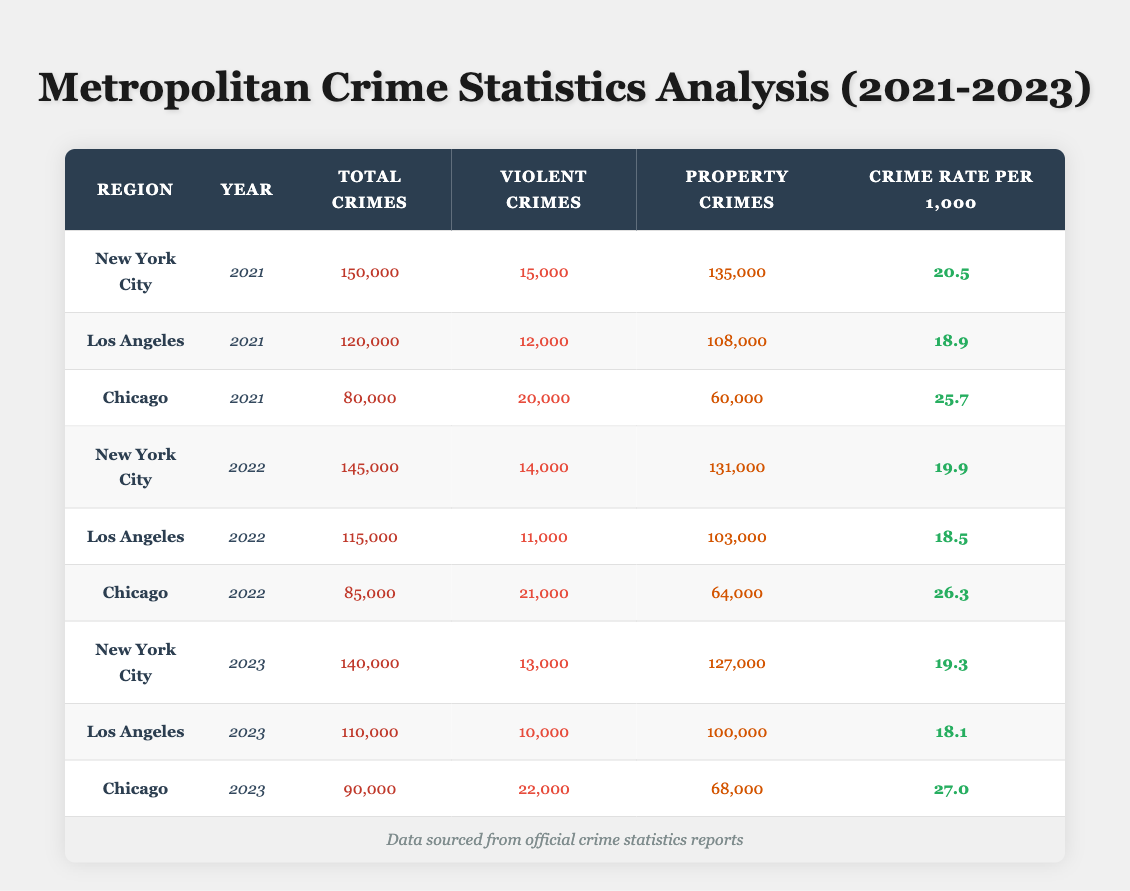What is the total number of violent crimes reported in Chicago in 2022? In the 2022 row for Chicago, the table shows that the number of violent crimes is listed as 21,000.
Answer: 21,000 How many total crimes were reported in Los Angeles in 2021? Referring to the 2021 row for Los Angeles in the table, the total crimes are stated as 120,000.
Answer: 120,000 What was the crime rate per 1,000 people in New York City in 2023? Looking at the 2023 row for New York City, the crime rate per 1,000 is provided as 19.3.
Answer: 19.3 Which region had the highest number of property crimes in 2021? In the 2021 data, New York City reported 135,000 property crimes, Los Angeles reported 108,000, and Chicago had 60,000. Comparing these figures, New York City has the highest at 135,000.
Answer: New York City What is the difference in total crimes between New York City in 2021 and Los Angeles in 2022? The total crimes for New York City in 2021 are 150,000 and for Los Angeles in 2022 are 115,000. The difference is calculated as 150,000 - 115,000 = 35,000.
Answer: 35,000 Did the total number of crimes in Chicago increase or decrease from 2022 to 2023? In 2022, Chicago had 85,000 total crimes, and in 2023 it was 90,000. Since 90,000 is greater than 85,000, it indicates an increase.
Answer: Increase Which region reported the lowest crime rate in 2023? In 2023, New York City had a crime rate of 19.3, Los Angeles had 18.1, and Chicago had 27.0. Comparing these rates, Los Angeles has the lowest at 18.1.
Answer: Los Angeles What was the average number of total crimes reported across all regions in 2022? For 2022, New York City had 145,000, Los Angeles had 115,000, and Chicago had 85,000. Summing these figures gives 145,000 + 115,000 + 85,000 = 345,000. Dividing by 3 regions yields an average of 345,000 / 3 = 115,000.
Answer: 115,000 How many violent crimes were reported in Los Angeles across all three years? The violent crimes reported in Los Angeles for each year are: 2021: 12,000, 2022: 11,000, 2023: 10,000. Adding these values gives 12,000 + 11,000 + 10,000 = 33,000.
Answer: 33,000 